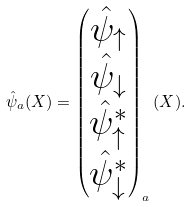<formula> <loc_0><loc_0><loc_500><loc_500>\hat { \psi } _ { a } ( X ) = \begin{pmatrix} \hat { \psi } _ { \uparrow } \\ \hat { \psi } _ { \downarrow } \\ \hat { \psi } _ { \uparrow } ^ { * } \\ \hat { \psi } _ { \downarrow } ^ { * } \end{pmatrix} _ { a } ( X ) .</formula> 